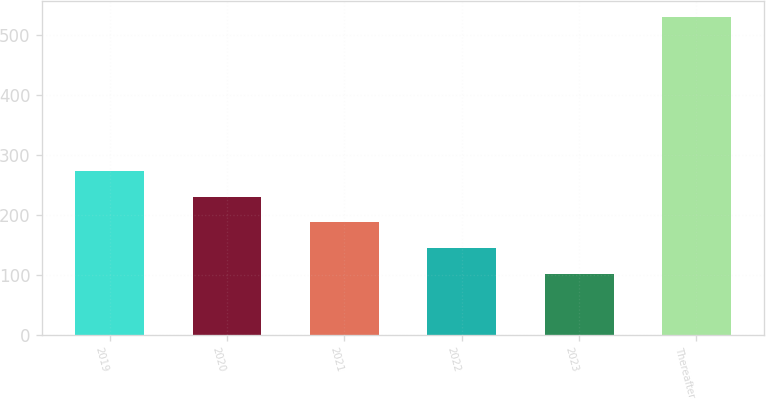Convert chart. <chart><loc_0><loc_0><loc_500><loc_500><bar_chart><fcel>2019<fcel>2020<fcel>2021<fcel>2022<fcel>2023<fcel>Thereafter<nl><fcel>273.24<fcel>230.38<fcel>187.52<fcel>144.66<fcel>101.8<fcel>530.4<nl></chart> 